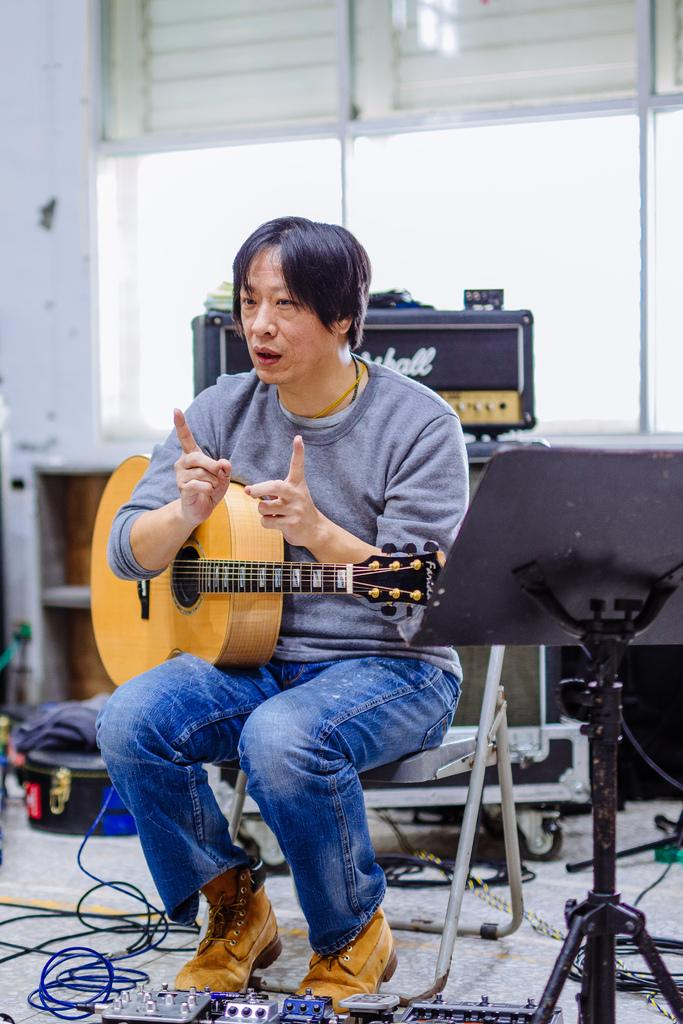What is the man in the image doing? The man is seated in the image. What is the man sitting on? The man is seated on a chair. What object is the man holding? The man is holding a guitar. What is in front of the man? There is a stand in front of the man. What else can be seen in the image related to music? There are musical instruments visible in the image. How much profit did the man make from playing the guitar in the image? There is no information about profit or financial gain in the image, as it focuses on the man's actions and the objects around him. 